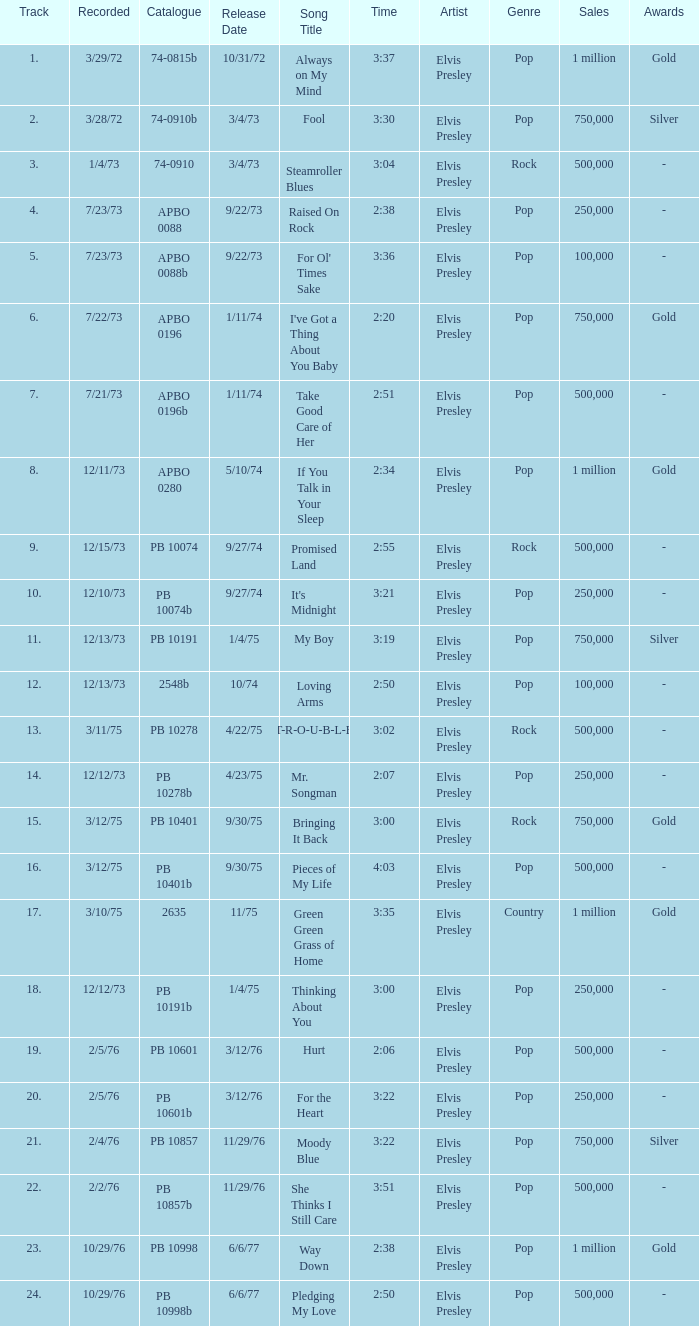I want the sum of tracks for raised on rock 4.0. 